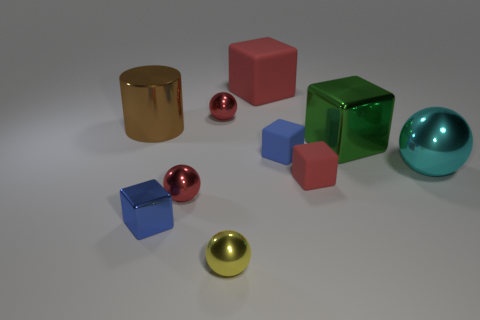Subtract all cyan shiny balls. How many balls are left? 3 Subtract all red cylinders. How many blue cubes are left? 2 Subtract all green cubes. How many cubes are left? 4 Subtract all spheres. How many objects are left? 6 Subtract all green balls. Subtract all purple blocks. How many balls are left? 4 Add 6 big purple blocks. How many big purple blocks exist? 6 Subtract 0 green cylinders. How many objects are left? 10 Subtract all blue shiny cubes. Subtract all small blocks. How many objects are left? 6 Add 1 big brown metallic objects. How many big brown metallic objects are left? 2 